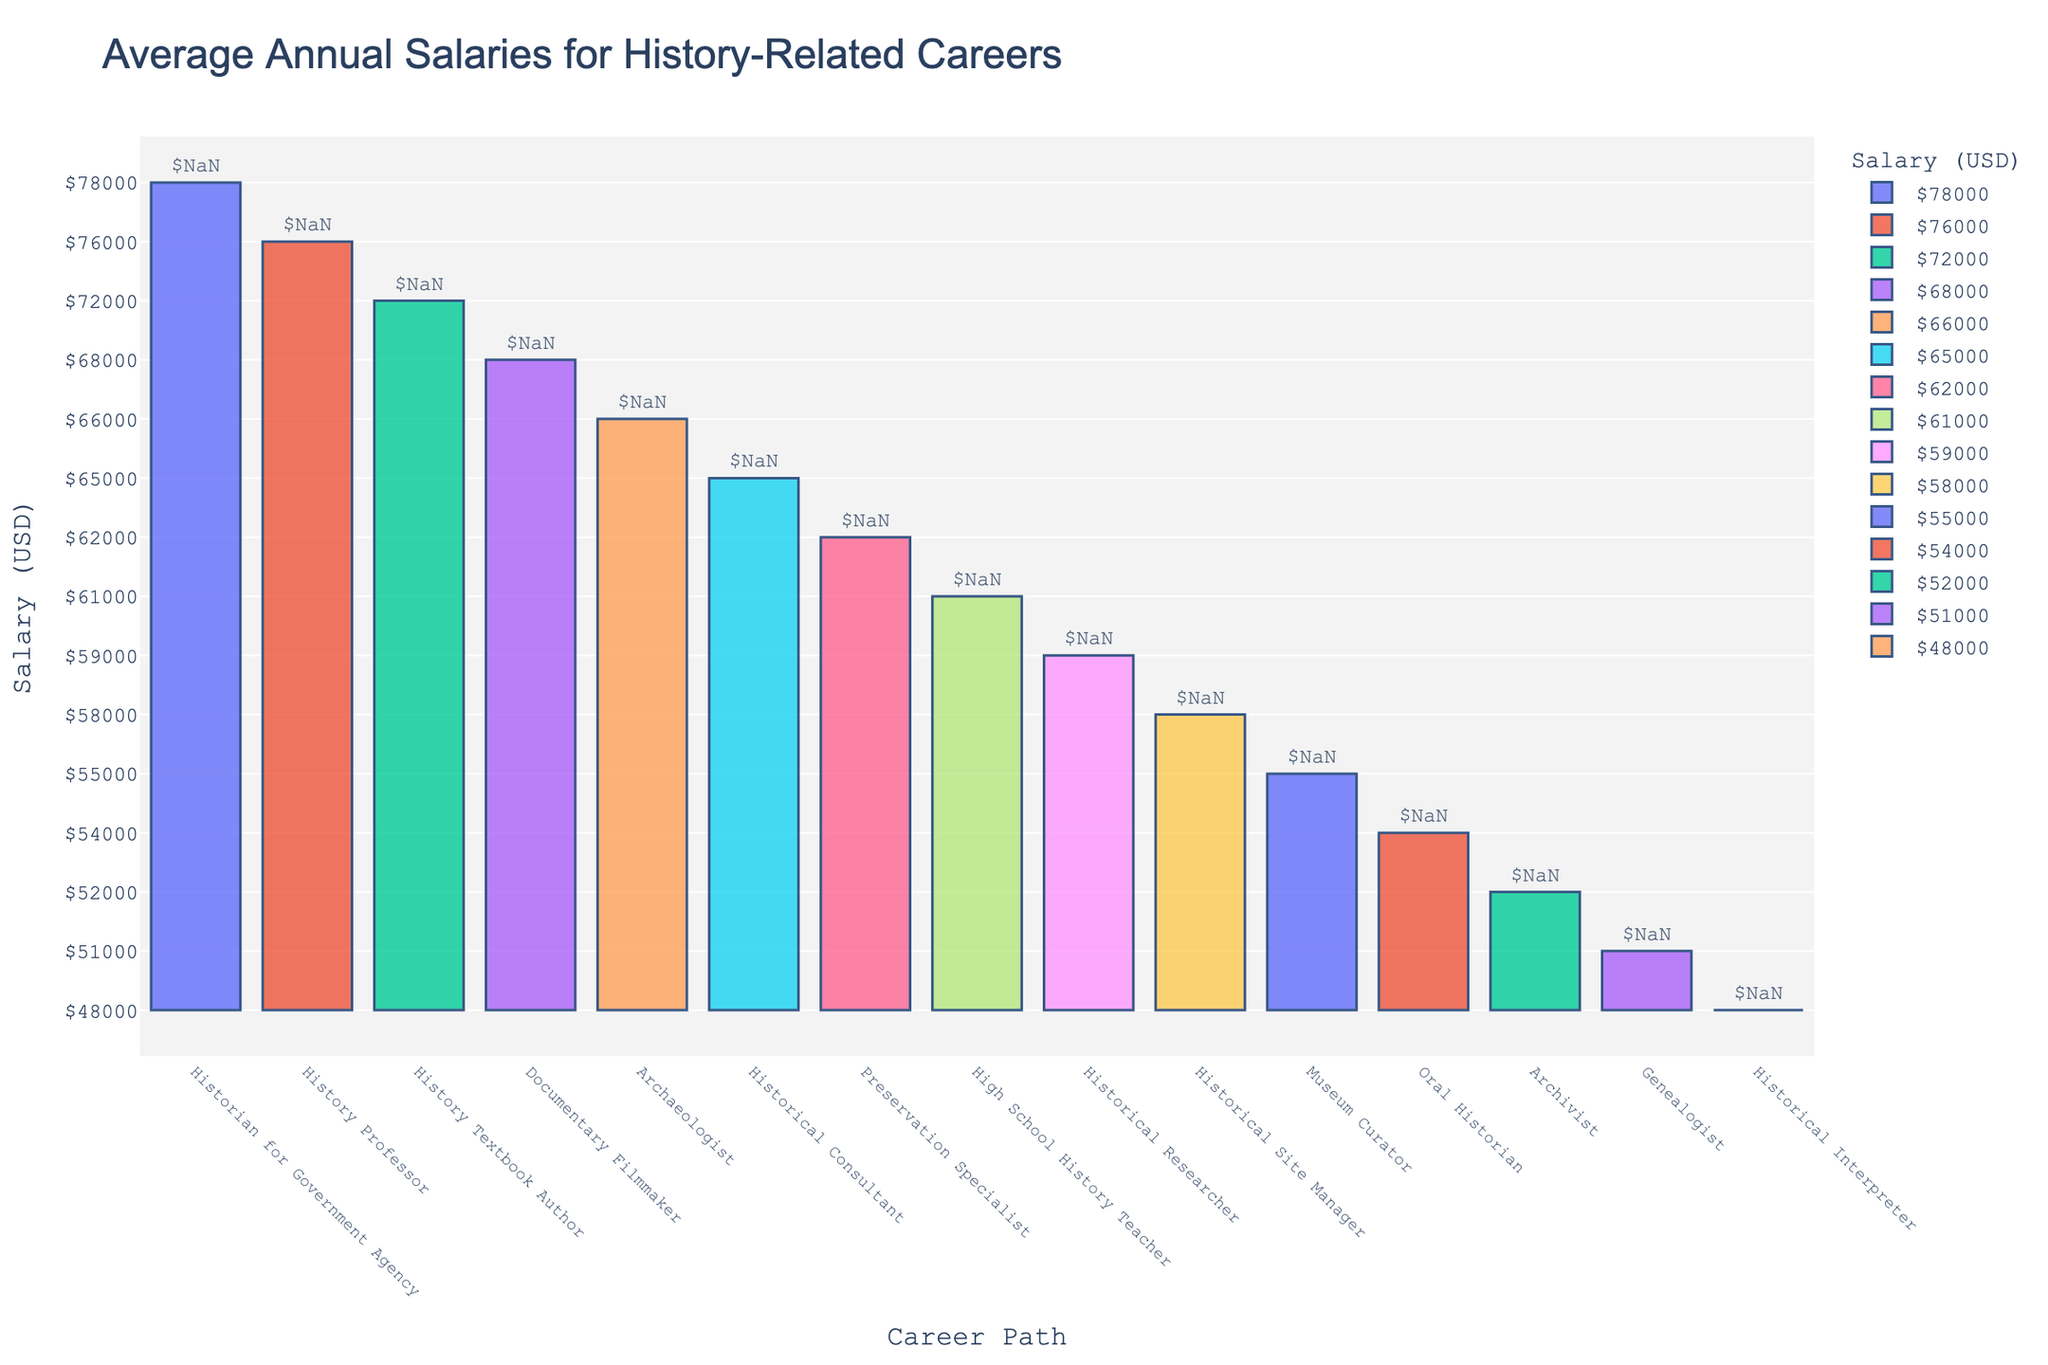Which career path has the highest average annual salary? Identify the tallest bar in the bar chart which represents the highest average salary.
Answer: Historian for Government Agency What is the difference in average annual salary between a History Professor and an Archivist? Find the bars for a History Professor ($76,000) and an Archivist ($52,000). Subtract the smaller value from the larger one: $76,000 - $52,000.
Answer: $24,000 Which career path has a lower average annual salary, Historical Interpreter or Genealogist? Compare the heights of the bars for Historical Interpreter ($48,000) and Genealogist ($51,000); the shorter bar indicates the lower salary.
Answer: Historical Interpreter What is the combined average annual salary of a Museum Curator, an Oral Historian, and a High School History Teacher? Add the average annual salaries of Museum Curator ($55,000), Oral Historian ($54,000), and High School History Teacher ($61,000): $55,000 + $54,000 + $61,000.
Answer: $170,000 Which two career paths are closest in average annual salary? Look at the bars that have nearly the same height and identify the salaries. In this case, a Historical Site Manager ($58,000) and a Historical Researcher ($59,000) are very close.
Answer: Historical Site Manager and Historical Researcher What is the average of the average annual salaries for a History Textbook Author and a Documentary Filmmaker? Add the salaries of History Textbook Author ($72,000) and Documentary Filmmaker ($68,000) together and divide by 2 to find the average: ($72,000 + $68,000) / 2.
Answer: $70,000 Which career path is represented by the longest bar in the chart? Identify the bar that extends the furthest upwards (the longest one). This path is the Historian for Government Agency.
Answer: Historian for Government Agency How much more does a Historical Consultant make on average compared to a Museum Curator? Compare their salaries: Historical Consultant ($65,000) and Museum Curator ($55,000). Subtract the smaller value from the larger one: $65,000 - $55,000.
Answer: $10,000 If you sum the average annual salaries for a Genealogist and a Historical Interpreter, what is the result? Add the average annual salaries of Genealogist ($51,000) and Historical Interpreter ($48,000): $51,000 + $48,000.
Answer: $99,000 Is the average annual salary for a Preservation Specialist higher or lower than that for an Archaeologist? Compare the heights of the bars for Preservation Specialist ($62,000) and Archaeologist ($66,000); the taller bar indicates the higher salary.
Answer: Lower 